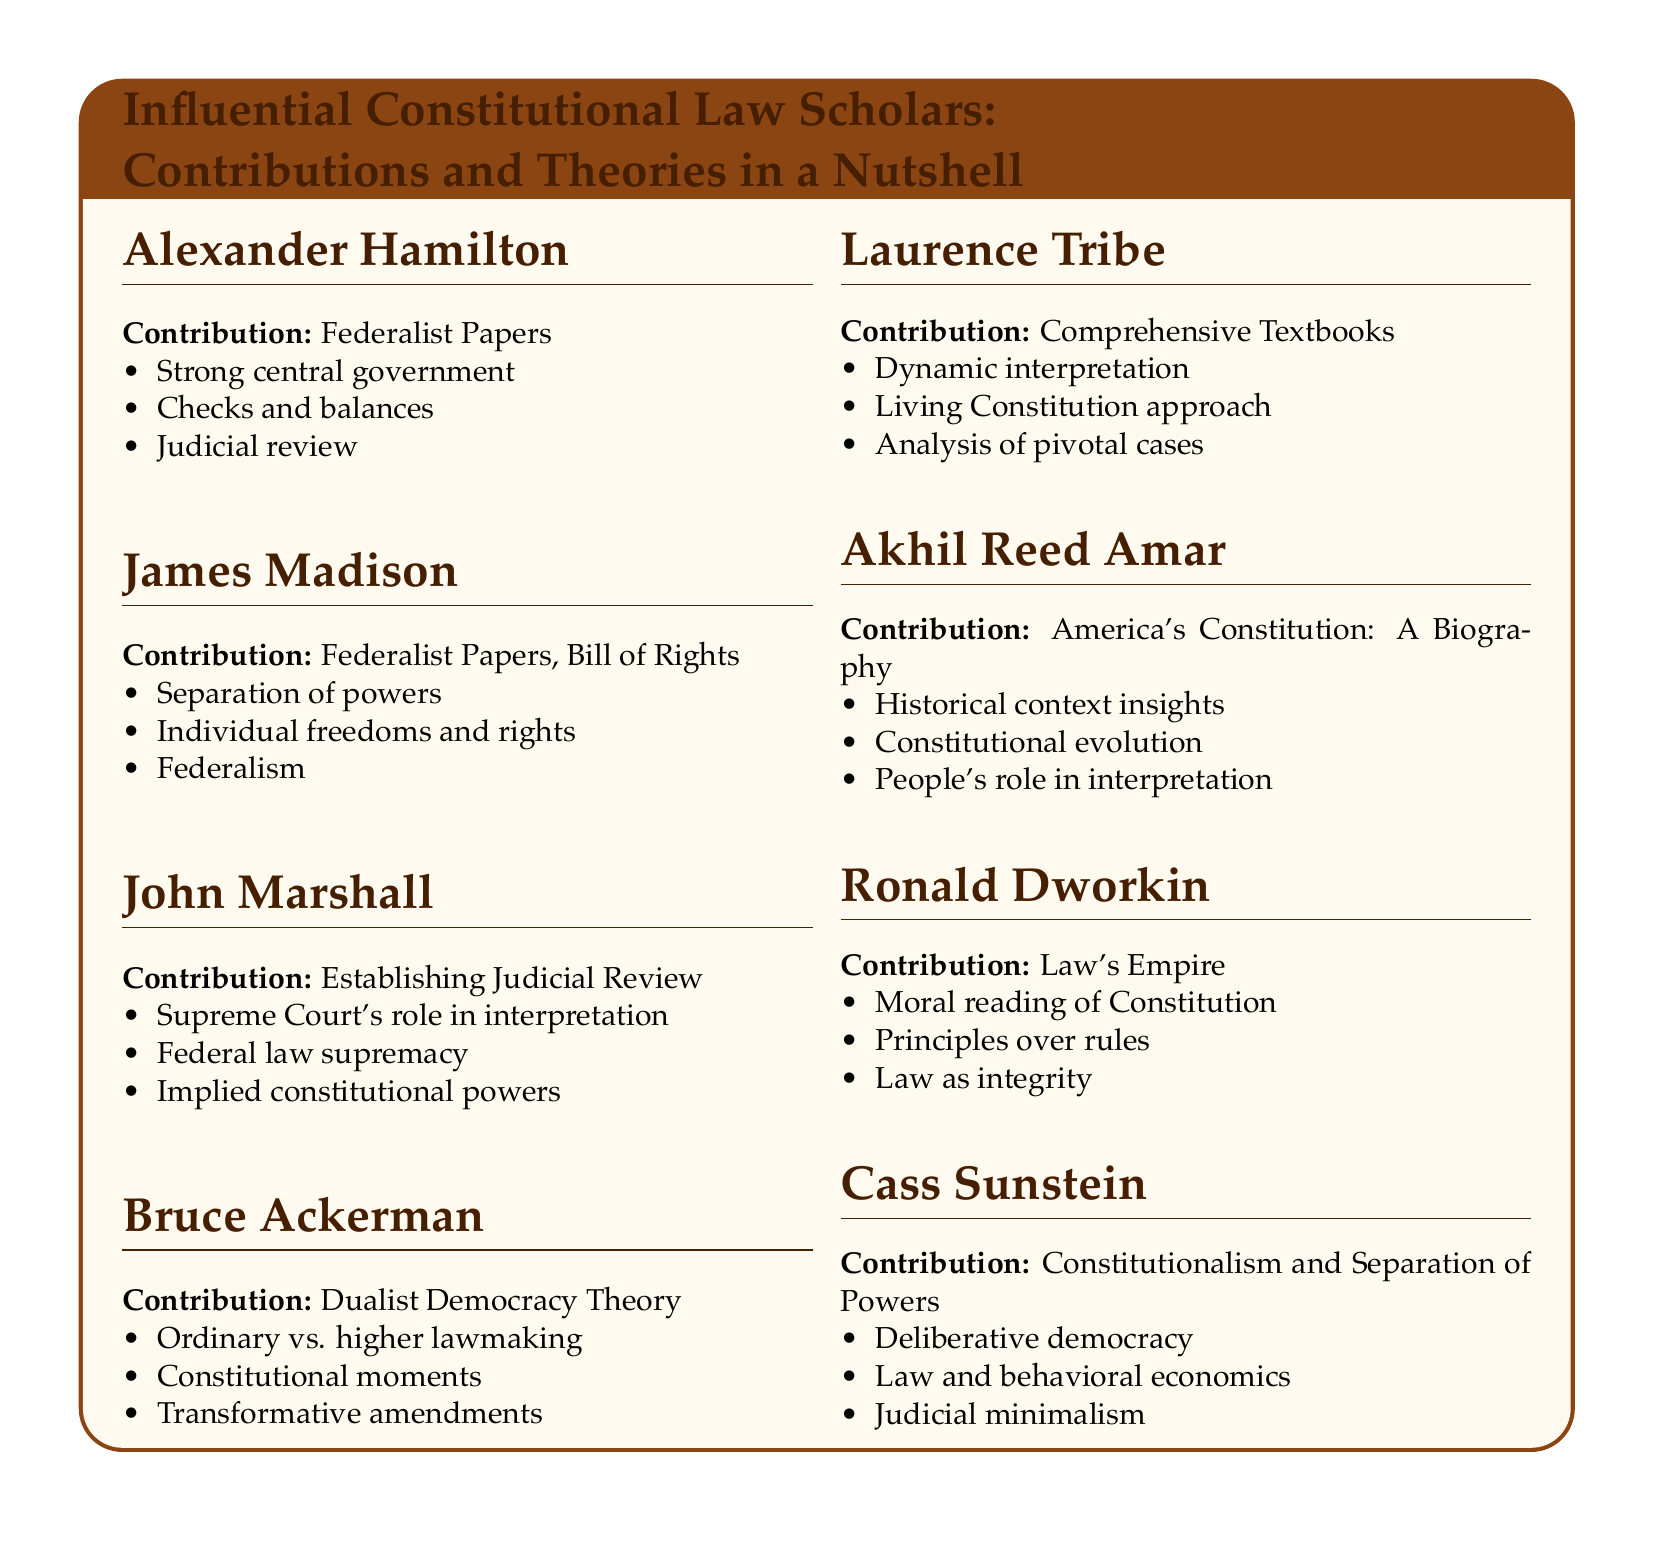What is the contribution of Alexander Hamilton? Alexander Hamilton is known for his role in the Federalist Papers, emphasizing a strong central government among other points.
Answer: Federalist Papers What theory did Bruce Ackerman develop? Bruce Ackerman is associated with the Dualist Democracy Theory, which discusses ordinary and higher lawmaking.
Answer: Dualist Democracy Theory Who established Judicial Review? The document states that John Marshall is credited with establishing the concept of judicial review.
Answer: John Marshall What is Maurice Tribe known for? Laurence Tribe is recognized for his work on comprehensive textbooks pertaining to constitutional law.
Answer: Comprehensive Textbooks What principle does Ronald Dworkin advocate in Law's Empire? Ronald Dworkin promotes a moral reading of the Constitution, focusing on principles over rules.
Answer: Moral reading of Constitution Which scholar focuses on deliberative democracy? The document specifies that Cass Sunstein concentrates on constitutionalism and deliberative democracy.
Answer: Cass Sunstein What amendment concept does Bruce Ackerman discuss? He discusses transformative amendments within his Dualist Democracy Theory framework.
Answer: Transformative amendments Which document is Akhil Reed Amar known for authoring? Akhil Reed Amar is known for his work titled "America's Constitution: A Biography."
Answer: America's Constitution: A Biography How many influential scholars are listed in the document? The document lists a total of seven influential constitutional law scholars along with their contributions.
Answer: Seven 